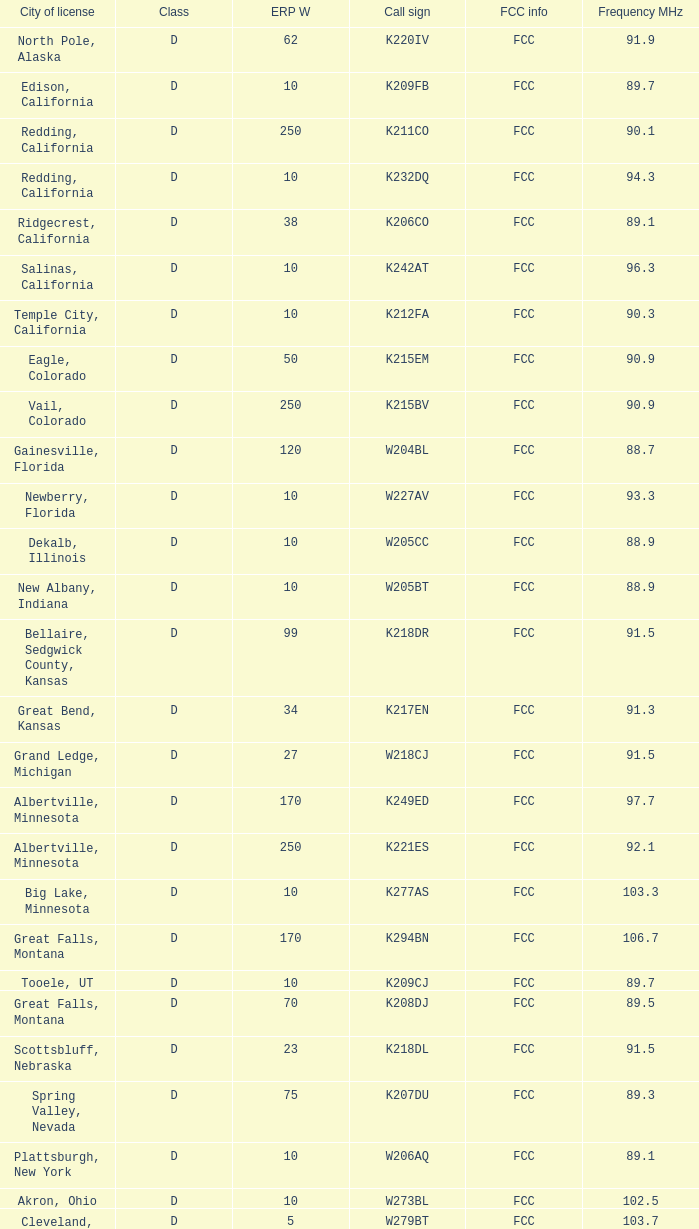What is the call sign of the translator in Spring Valley, Nevada? K207DU. 